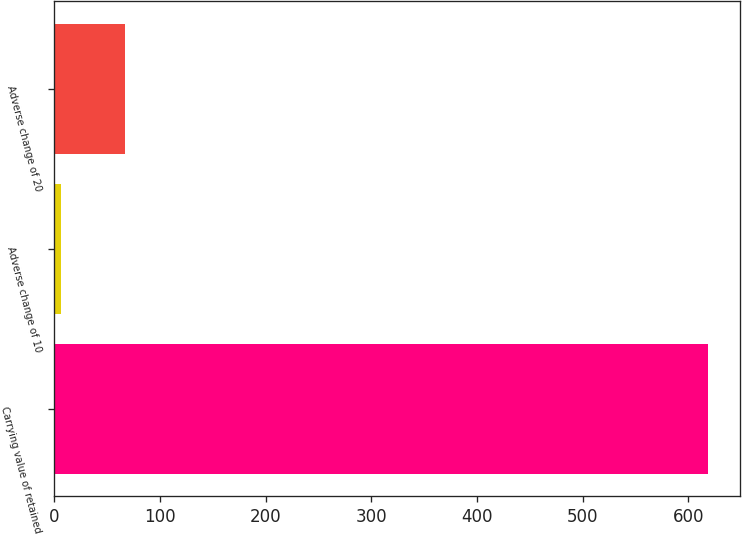Convert chart. <chart><loc_0><loc_0><loc_500><loc_500><bar_chart><fcel>Carrying value of retained<fcel>Adverse change of 10<fcel>Adverse change of 20<nl><fcel>618<fcel>6<fcel>67.2<nl></chart> 